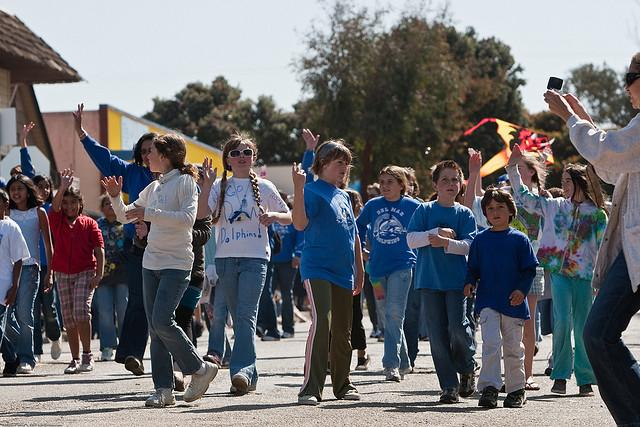Why is the woman on the right holding an object in her hands?

Choices:
A) hitting balls
B) taking photos
C) exercising
D) playing games taking photos 